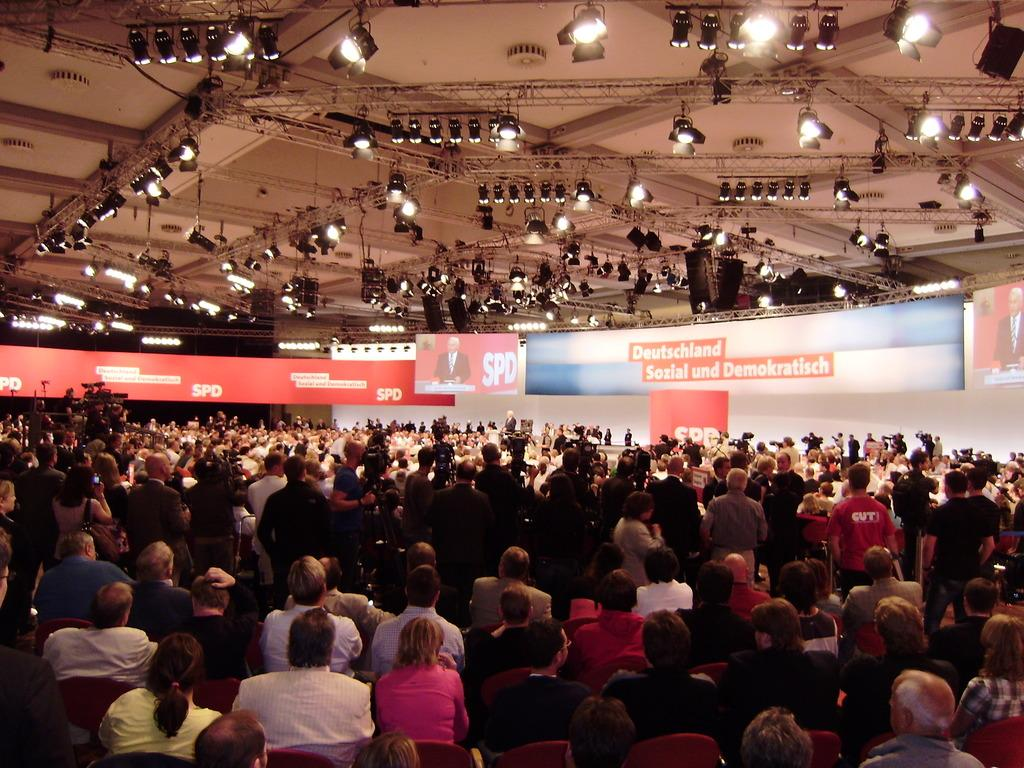How many people are present in the image? There are many people in the image. What can be seen attached to the roof in the image? There are lights attached to the roof in the image. What type of signage is present in the image? There are advertising boards in the image. How many digital screens are visible in the image? There are two digital screens in the image. What type of fruit can be seen hanging from the advertising boards in the image? There is no fruit, such as a pear, visible on the advertising boards in the image. 